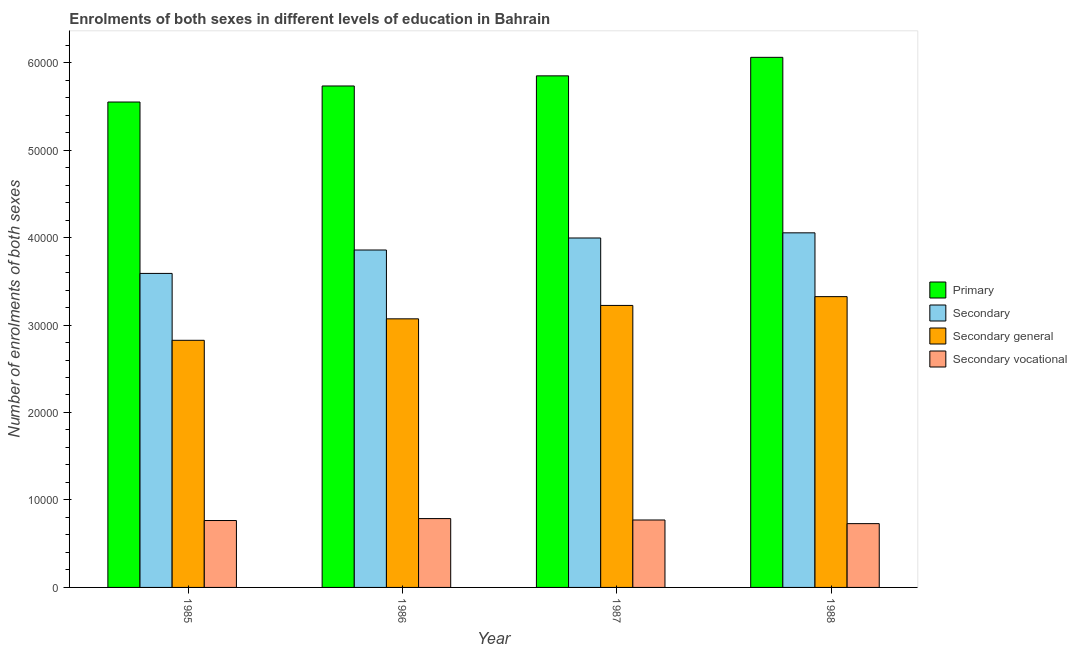How many different coloured bars are there?
Make the answer very short. 4. Are the number of bars per tick equal to the number of legend labels?
Keep it short and to the point. Yes. In how many cases, is the number of bars for a given year not equal to the number of legend labels?
Give a very brief answer. 0. What is the number of enrolments in secondary general education in 1985?
Give a very brief answer. 2.83e+04. Across all years, what is the maximum number of enrolments in primary education?
Make the answer very short. 6.06e+04. Across all years, what is the minimum number of enrolments in primary education?
Your response must be concise. 5.55e+04. In which year was the number of enrolments in secondary general education maximum?
Make the answer very short. 1988. In which year was the number of enrolments in secondary general education minimum?
Provide a succinct answer. 1985. What is the total number of enrolments in primary education in the graph?
Give a very brief answer. 2.32e+05. What is the difference between the number of enrolments in secondary vocational education in 1985 and that in 1988?
Provide a short and direct response. 354. What is the difference between the number of enrolments in secondary education in 1986 and the number of enrolments in secondary general education in 1987?
Keep it short and to the point. -1374. What is the average number of enrolments in secondary general education per year?
Offer a very short reply. 3.11e+04. What is the ratio of the number of enrolments in secondary general education in 1985 to that in 1987?
Offer a terse response. 0.88. Is the number of enrolments in secondary education in 1986 less than that in 1987?
Offer a terse response. Yes. Is the difference between the number of enrolments in secondary education in 1987 and 1988 greater than the difference between the number of enrolments in secondary general education in 1987 and 1988?
Make the answer very short. No. What is the difference between the highest and the second highest number of enrolments in primary education?
Your answer should be compact. 2117. What is the difference between the highest and the lowest number of enrolments in secondary vocational education?
Provide a succinct answer. 576. In how many years, is the number of enrolments in secondary general education greater than the average number of enrolments in secondary general education taken over all years?
Make the answer very short. 2. Is the sum of the number of enrolments in secondary vocational education in 1986 and 1987 greater than the maximum number of enrolments in primary education across all years?
Provide a short and direct response. Yes. Is it the case that in every year, the sum of the number of enrolments in primary education and number of enrolments in secondary education is greater than the sum of number of enrolments in secondary general education and number of enrolments in secondary vocational education?
Ensure brevity in your answer.  Yes. What does the 4th bar from the left in 1985 represents?
Your answer should be compact. Secondary vocational. What does the 1st bar from the right in 1986 represents?
Make the answer very short. Secondary vocational. How many bars are there?
Give a very brief answer. 16. Are all the bars in the graph horizontal?
Offer a terse response. No. How many years are there in the graph?
Provide a short and direct response. 4. Are the values on the major ticks of Y-axis written in scientific E-notation?
Give a very brief answer. No. What is the title of the graph?
Provide a succinct answer. Enrolments of both sexes in different levels of education in Bahrain. What is the label or title of the X-axis?
Give a very brief answer. Year. What is the label or title of the Y-axis?
Keep it short and to the point. Number of enrolments of both sexes. What is the Number of enrolments of both sexes in Primary in 1985?
Provide a short and direct response. 5.55e+04. What is the Number of enrolments of both sexes in Secondary in 1985?
Your answer should be compact. 3.59e+04. What is the Number of enrolments of both sexes of Secondary general in 1985?
Make the answer very short. 2.83e+04. What is the Number of enrolments of both sexes in Secondary vocational in 1985?
Ensure brevity in your answer.  7648. What is the Number of enrolments of both sexes in Primary in 1986?
Provide a short and direct response. 5.73e+04. What is the Number of enrolments of both sexes in Secondary in 1986?
Keep it short and to the point. 3.86e+04. What is the Number of enrolments of both sexes in Secondary general in 1986?
Your answer should be compact. 3.07e+04. What is the Number of enrolments of both sexes of Secondary vocational in 1986?
Your answer should be compact. 7870. What is the Number of enrolments of both sexes of Primary in 1987?
Offer a very short reply. 5.85e+04. What is the Number of enrolments of both sexes in Secondary in 1987?
Provide a short and direct response. 4.00e+04. What is the Number of enrolments of both sexes in Secondary general in 1987?
Make the answer very short. 3.22e+04. What is the Number of enrolments of both sexes of Secondary vocational in 1987?
Offer a terse response. 7710. What is the Number of enrolments of both sexes in Primary in 1988?
Ensure brevity in your answer.  6.06e+04. What is the Number of enrolments of both sexes of Secondary in 1988?
Keep it short and to the point. 4.05e+04. What is the Number of enrolments of both sexes of Secondary general in 1988?
Give a very brief answer. 3.32e+04. What is the Number of enrolments of both sexes in Secondary vocational in 1988?
Give a very brief answer. 7294. Across all years, what is the maximum Number of enrolments of both sexes in Primary?
Provide a short and direct response. 6.06e+04. Across all years, what is the maximum Number of enrolments of both sexes in Secondary?
Your answer should be very brief. 4.05e+04. Across all years, what is the maximum Number of enrolments of both sexes in Secondary general?
Give a very brief answer. 3.32e+04. Across all years, what is the maximum Number of enrolments of both sexes of Secondary vocational?
Give a very brief answer. 7870. Across all years, what is the minimum Number of enrolments of both sexes in Primary?
Your response must be concise. 5.55e+04. Across all years, what is the minimum Number of enrolments of both sexes in Secondary?
Make the answer very short. 3.59e+04. Across all years, what is the minimum Number of enrolments of both sexes of Secondary general?
Your response must be concise. 2.83e+04. Across all years, what is the minimum Number of enrolments of both sexes of Secondary vocational?
Make the answer very short. 7294. What is the total Number of enrolments of both sexes in Primary in the graph?
Give a very brief answer. 2.32e+05. What is the total Number of enrolments of both sexes of Secondary in the graph?
Your answer should be compact. 1.55e+05. What is the total Number of enrolments of both sexes in Secondary general in the graph?
Your answer should be very brief. 1.24e+05. What is the total Number of enrolments of both sexes in Secondary vocational in the graph?
Provide a succinct answer. 3.05e+04. What is the difference between the Number of enrolments of both sexes in Primary in 1985 and that in 1986?
Keep it short and to the point. -1834. What is the difference between the Number of enrolments of both sexes of Secondary in 1985 and that in 1986?
Provide a succinct answer. -2676. What is the difference between the Number of enrolments of both sexes of Secondary general in 1985 and that in 1986?
Provide a succinct answer. -2454. What is the difference between the Number of enrolments of both sexes in Secondary vocational in 1985 and that in 1986?
Provide a succinct answer. -222. What is the difference between the Number of enrolments of both sexes in Primary in 1985 and that in 1987?
Keep it short and to the point. -2992. What is the difference between the Number of enrolments of both sexes in Secondary in 1985 and that in 1987?
Provide a succinct answer. -4050. What is the difference between the Number of enrolments of both sexes of Secondary general in 1985 and that in 1987?
Your answer should be very brief. -3988. What is the difference between the Number of enrolments of both sexes in Secondary vocational in 1985 and that in 1987?
Give a very brief answer. -62. What is the difference between the Number of enrolments of both sexes in Primary in 1985 and that in 1988?
Give a very brief answer. -5109. What is the difference between the Number of enrolments of both sexes in Secondary in 1985 and that in 1988?
Your response must be concise. -4639. What is the difference between the Number of enrolments of both sexes in Secondary general in 1985 and that in 1988?
Ensure brevity in your answer.  -4993. What is the difference between the Number of enrolments of both sexes in Secondary vocational in 1985 and that in 1988?
Provide a short and direct response. 354. What is the difference between the Number of enrolments of both sexes in Primary in 1986 and that in 1987?
Provide a succinct answer. -1158. What is the difference between the Number of enrolments of both sexes of Secondary in 1986 and that in 1987?
Your answer should be compact. -1374. What is the difference between the Number of enrolments of both sexes in Secondary general in 1986 and that in 1987?
Give a very brief answer. -1534. What is the difference between the Number of enrolments of both sexes in Secondary vocational in 1986 and that in 1987?
Ensure brevity in your answer.  160. What is the difference between the Number of enrolments of both sexes of Primary in 1986 and that in 1988?
Give a very brief answer. -3275. What is the difference between the Number of enrolments of both sexes of Secondary in 1986 and that in 1988?
Make the answer very short. -1963. What is the difference between the Number of enrolments of both sexes of Secondary general in 1986 and that in 1988?
Your answer should be compact. -2539. What is the difference between the Number of enrolments of both sexes in Secondary vocational in 1986 and that in 1988?
Provide a succinct answer. 576. What is the difference between the Number of enrolments of both sexes of Primary in 1987 and that in 1988?
Keep it short and to the point. -2117. What is the difference between the Number of enrolments of both sexes in Secondary in 1987 and that in 1988?
Make the answer very short. -589. What is the difference between the Number of enrolments of both sexes of Secondary general in 1987 and that in 1988?
Ensure brevity in your answer.  -1005. What is the difference between the Number of enrolments of both sexes of Secondary vocational in 1987 and that in 1988?
Give a very brief answer. 416. What is the difference between the Number of enrolments of both sexes in Primary in 1985 and the Number of enrolments of both sexes in Secondary in 1986?
Give a very brief answer. 1.69e+04. What is the difference between the Number of enrolments of both sexes in Primary in 1985 and the Number of enrolments of both sexes in Secondary general in 1986?
Give a very brief answer. 2.48e+04. What is the difference between the Number of enrolments of both sexes of Primary in 1985 and the Number of enrolments of both sexes of Secondary vocational in 1986?
Make the answer very short. 4.76e+04. What is the difference between the Number of enrolments of both sexes in Secondary in 1985 and the Number of enrolments of both sexes in Secondary general in 1986?
Give a very brief answer. 5194. What is the difference between the Number of enrolments of both sexes of Secondary in 1985 and the Number of enrolments of both sexes of Secondary vocational in 1986?
Provide a short and direct response. 2.80e+04. What is the difference between the Number of enrolments of both sexes of Secondary general in 1985 and the Number of enrolments of both sexes of Secondary vocational in 1986?
Your answer should be very brief. 2.04e+04. What is the difference between the Number of enrolments of both sexes of Primary in 1985 and the Number of enrolments of both sexes of Secondary in 1987?
Ensure brevity in your answer.  1.55e+04. What is the difference between the Number of enrolments of both sexes of Primary in 1985 and the Number of enrolments of both sexes of Secondary general in 1987?
Provide a succinct answer. 2.33e+04. What is the difference between the Number of enrolments of both sexes in Primary in 1985 and the Number of enrolments of both sexes in Secondary vocational in 1987?
Your response must be concise. 4.78e+04. What is the difference between the Number of enrolments of both sexes of Secondary in 1985 and the Number of enrolments of both sexes of Secondary general in 1987?
Make the answer very short. 3660. What is the difference between the Number of enrolments of both sexes in Secondary in 1985 and the Number of enrolments of both sexes in Secondary vocational in 1987?
Provide a short and direct response. 2.82e+04. What is the difference between the Number of enrolments of both sexes of Secondary general in 1985 and the Number of enrolments of both sexes of Secondary vocational in 1987?
Provide a succinct answer. 2.05e+04. What is the difference between the Number of enrolments of both sexes of Primary in 1985 and the Number of enrolments of both sexes of Secondary in 1988?
Your answer should be very brief. 1.50e+04. What is the difference between the Number of enrolments of both sexes of Primary in 1985 and the Number of enrolments of both sexes of Secondary general in 1988?
Keep it short and to the point. 2.22e+04. What is the difference between the Number of enrolments of both sexes in Primary in 1985 and the Number of enrolments of both sexes in Secondary vocational in 1988?
Provide a short and direct response. 4.82e+04. What is the difference between the Number of enrolments of both sexes in Secondary in 1985 and the Number of enrolments of both sexes in Secondary general in 1988?
Your answer should be compact. 2655. What is the difference between the Number of enrolments of both sexes of Secondary in 1985 and the Number of enrolments of both sexes of Secondary vocational in 1988?
Provide a short and direct response. 2.86e+04. What is the difference between the Number of enrolments of both sexes in Secondary general in 1985 and the Number of enrolments of both sexes in Secondary vocational in 1988?
Keep it short and to the point. 2.10e+04. What is the difference between the Number of enrolments of both sexes in Primary in 1986 and the Number of enrolments of both sexes in Secondary in 1987?
Provide a short and direct response. 1.74e+04. What is the difference between the Number of enrolments of both sexes of Primary in 1986 and the Number of enrolments of both sexes of Secondary general in 1987?
Provide a succinct answer. 2.51e+04. What is the difference between the Number of enrolments of both sexes of Primary in 1986 and the Number of enrolments of both sexes of Secondary vocational in 1987?
Provide a short and direct response. 4.96e+04. What is the difference between the Number of enrolments of both sexes of Secondary in 1986 and the Number of enrolments of both sexes of Secondary general in 1987?
Your answer should be very brief. 6336. What is the difference between the Number of enrolments of both sexes of Secondary in 1986 and the Number of enrolments of both sexes of Secondary vocational in 1987?
Provide a succinct answer. 3.09e+04. What is the difference between the Number of enrolments of both sexes of Secondary general in 1986 and the Number of enrolments of both sexes of Secondary vocational in 1987?
Your answer should be very brief. 2.30e+04. What is the difference between the Number of enrolments of both sexes of Primary in 1986 and the Number of enrolments of both sexes of Secondary in 1988?
Offer a very short reply. 1.68e+04. What is the difference between the Number of enrolments of both sexes in Primary in 1986 and the Number of enrolments of both sexes in Secondary general in 1988?
Ensure brevity in your answer.  2.41e+04. What is the difference between the Number of enrolments of both sexes in Primary in 1986 and the Number of enrolments of both sexes in Secondary vocational in 1988?
Offer a terse response. 5.00e+04. What is the difference between the Number of enrolments of both sexes of Secondary in 1986 and the Number of enrolments of both sexes of Secondary general in 1988?
Provide a succinct answer. 5331. What is the difference between the Number of enrolments of both sexes of Secondary in 1986 and the Number of enrolments of both sexes of Secondary vocational in 1988?
Your answer should be compact. 3.13e+04. What is the difference between the Number of enrolments of both sexes in Secondary general in 1986 and the Number of enrolments of both sexes in Secondary vocational in 1988?
Your answer should be very brief. 2.34e+04. What is the difference between the Number of enrolments of both sexes in Primary in 1987 and the Number of enrolments of both sexes in Secondary in 1988?
Your answer should be very brief. 1.79e+04. What is the difference between the Number of enrolments of both sexes of Primary in 1987 and the Number of enrolments of both sexes of Secondary general in 1988?
Offer a very short reply. 2.52e+04. What is the difference between the Number of enrolments of both sexes of Primary in 1987 and the Number of enrolments of both sexes of Secondary vocational in 1988?
Make the answer very short. 5.12e+04. What is the difference between the Number of enrolments of both sexes in Secondary in 1987 and the Number of enrolments of both sexes in Secondary general in 1988?
Your response must be concise. 6705. What is the difference between the Number of enrolments of both sexes in Secondary in 1987 and the Number of enrolments of both sexes in Secondary vocational in 1988?
Make the answer very short. 3.27e+04. What is the difference between the Number of enrolments of both sexes in Secondary general in 1987 and the Number of enrolments of both sexes in Secondary vocational in 1988?
Offer a very short reply. 2.49e+04. What is the average Number of enrolments of both sexes of Primary per year?
Provide a succinct answer. 5.80e+04. What is the average Number of enrolments of both sexes of Secondary per year?
Ensure brevity in your answer.  3.87e+04. What is the average Number of enrolments of both sexes in Secondary general per year?
Give a very brief answer. 3.11e+04. What is the average Number of enrolments of both sexes of Secondary vocational per year?
Your answer should be compact. 7630.5. In the year 1985, what is the difference between the Number of enrolments of both sexes of Primary and Number of enrolments of both sexes of Secondary?
Your response must be concise. 1.96e+04. In the year 1985, what is the difference between the Number of enrolments of both sexes of Primary and Number of enrolments of both sexes of Secondary general?
Your answer should be compact. 2.72e+04. In the year 1985, what is the difference between the Number of enrolments of both sexes of Primary and Number of enrolments of both sexes of Secondary vocational?
Your answer should be very brief. 4.78e+04. In the year 1985, what is the difference between the Number of enrolments of both sexes in Secondary and Number of enrolments of both sexes in Secondary general?
Give a very brief answer. 7648. In the year 1985, what is the difference between the Number of enrolments of both sexes of Secondary and Number of enrolments of both sexes of Secondary vocational?
Offer a terse response. 2.83e+04. In the year 1985, what is the difference between the Number of enrolments of both sexes in Secondary general and Number of enrolments of both sexes in Secondary vocational?
Ensure brevity in your answer.  2.06e+04. In the year 1986, what is the difference between the Number of enrolments of both sexes in Primary and Number of enrolments of both sexes in Secondary?
Your answer should be compact. 1.88e+04. In the year 1986, what is the difference between the Number of enrolments of both sexes of Primary and Number of enrolments of both sexes of Secondary general?
Offer a very short reply. 2.66e+04. In the year 1986, what is the difference between the Number of enrolments of both sexes of Primary and Number of enrolments of both sexes of Secondary vocational?
Keep it short and to the point. 4.95e+04. In the year 1986, what is the difference between the Number of enrolments of both sexes of Secondary and Number of enrolments of both sexes of Secondary general?
Provide a short and direct response. 7870. In the year 1986, what is the difference between the Number of enrolments of both sexes of Secondary and Number of enrolments of both sexes of Secondary vocational?
Offer a very short reply. 3.07e+04. In the year 1986, what is the difference between the Number of enrolments of both sexes of Secondary general and Number of enrolments of both sexes of Secondary vocational?
Offer a terse response. 2.28e+04. In the year 1987, what is the difference between the Number of enrolments of both sexes in Primary and Number of enrolments of both sexes in Secondary?
Offer a terse response. 1.85e+04. In the year 1987, what is the difference between the Number of enrolments of both sexes in Primary and Number of enrolments of both sexes in Secondary general?
Keep it short and to the point. 2.62e+04. In the year 1987, what is the difference between the Number of enrolments of both sexes in Primary and Number of enrolments of both sexes in Secondary vocational?
Offer a very short reply. 5.08e+04. In the year 1987, what is the difference between the Number of enrolments of both sexes of Secondary and Number of enrolments of both sexes of Secondary general?
Give a very brief answer. 7710. In the year 1987, what is the difference between the Number of enrolments of both sexes of Secondary and Number of enrolments of both sexes of Secondary vocational?
Keep it short and to the point. 3.22e+04. In the year 1987, what is the difference between the Number of enrolments of both sexes of Secondary general and Number of enrolments of both sexes of Secondary vocational?
Provide a succinct answer. 2.45e+04. In the year 1988, what is the difference between the Number of enrolments of both sexes of Primary and Number of enrolments of both sexes of Secondary?
Offer a terse response. 2.01e+04. In the year 1988, what is the difference between the Number of enrolments of both sexes in Primary and Number of enrolments of both sexes in Secondary general?
Offer a terse response. 2.74e+04. In the year 1988, what is the difference between the Number of enrolments of both sexes in Primary and Number of enrolments of both sexes in Secondary vocational?
Provide a succinct answer. 5.33e+04. In the year 1988, what is the difference between the Number of enrolments of both sexes in Secondary and Number of enrolments of both sexes in Secondary general?
Ensure brevity in your answer.  7294. In the year 1988, what is the difference between the Number of enrolments of both sexes of Secondary and Number of enrolments of both sexes of Secondary vocational?
Your answer should be compact. 3.32e+04. In the year 1988, what is the difference between the Number of enrolments of both sexes in Secondary general and Number of enrolments of both sexes in Secondary vocational?
Ensure brevity in your answer.  2.60e+04. What is the ratio of the Number of enrolments of both sexes in Primary in 1985 to that in 1986?
Offer a very short reply. 0.97. What is the ratio of the Number of enrolments of both sexes in Secondary in 1985 to that in 1986?
Your answer should be compact. 0.93. What is the ratio of the Number of enrolments of both sexes in Secondary general in 1985 to that in 1986?
Keep it short and to the point. 0.92. What is the ratio of the Number of enrolments of both sexes of Secondary vocational in 1985 to that in 1986?
Ensure brevity in your answer.  0.97. What is the ratio of the Number of enrolments of both sexes in Primary in 1985 to that in 1987?
Your answer should be very brief. 0.95. What is the ratio of the Number of enrolments of both sexes of Secondary in 1985 to that in 1987?
Provide a succinct answer. 0.9. What is the ratio of the Number of enrolments of both sexes of Secondary general in 1985 to that in 1987?
Your answer should be very brief. 0.88. What is the ratio of the Number of enrolments of both sexes in Secondary vocational in 1985 to that in 1987?
Provide a succinct answer. 0.99. What is the ratio of the Number of enrolments of both sexes of Primary in 1985 to that in 1988?
Provide a short and direct response. 0.92. What is the ratio of the Number of enrolments of both sexes of Secondary in 1985 to that in 1988?
Offer a very short reply. 0.89. What is the ratio of the Number of enrolments of both sexes in Secondary general in 1985 to that in 1988?
Make the answer very short. 0.85. What is the ratio of the Number of enrolments of both sexes of Secondary vocational in 1985 to that in 1988?
Your response must be concise. 1.05. What is the ratio of the Number of enrolments of both sexes in Primary in 1986 to that in 1987?
Ensure brevity in your answer.  0.98. What is the ratio of the Number of enrolments of both sexes in Secondary in 1986 to that in 1987?
Offer a very short reply. 0.97. What is the ratio of the Number of enrolments of both sexes in Secondary vocational in 1986 to that in 1987?
Ensure brevity in your answer.  1.02. What is the ratio of the Number of enrolments of both sexes of Primary in 1986 to that in 1988?
Provide a succinct answer. 0.95. What is the ratio of the Number of enrolments of both sexes of Secondary in 1986 to that in 1988?
Your answer should be very brief. 0.95. What is the ratio of the Number of enrolments of both sexes in Secondary general in 1986 to that in 1988?
Your answer should be compact. 0.92. What is the ratio of the Number of enrolments of both sexes in Secondary vocational in 1986 to that in 1988?
Offer a very short reply. 1.08. What is the ratio of the Number of enrolments of both sexes of Primary in 1987 to that in 1988?
Keep it short and to the point. 0.97. What is the ratio of the Number of enrolments of both sexes in Secondary in 1987 to that in 1988?
Offer a terse response. 0.99. What is the ratio of the Number of enrolments of both sexes of Secondary general in 1987 to that in 1988?
Your answer should be very brief. 0.97. What is the ratio of the Number of enrolments of both sexes of Secondary vocational in 1987 to that in 1988?
Make the answer very short. 1.06. What is the difference between the highest and the second highest Number of enrolments of both sexes in Primary?
Make the answer very short. 2117. What is the difference between the highest and the second highest Number of enrolments of both sexes of Secondary?
Provide a succinct answer. 589. What is the difference between the highest and the second highest Number of enrolments of both sexes of Secondary general?
Make the answer very short. 1005. What is the difference between the highest and the second highest Number of enrolments of both sexes of Secondary vocational?
Provide a succinct answer. 160. What is the difference between the highest and the lowest Number of enrolments of both sexes in Primary?
Provide a short and direct response. 5109. What is the difference between the highest and the lowest Number of enrolments of both sexes in Secondary?
Keep it short and to the point. 4639. What is the difference between the highest and the lowest Number of enrolments of both sexes in Secondary general?
Your response must be concise. 4993. What is the difference between the highest and the lowest Number of enrolments of both sexes in Secondary vocational?
Provide a succinct answer. 576. 